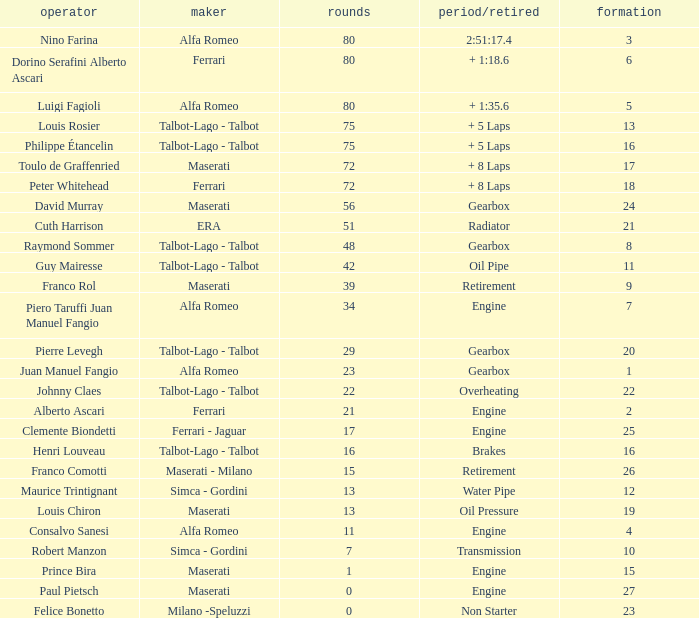When the driver is Juan Manuel Fangio and laps is less than 39, what is the highest grid? 1.0. 